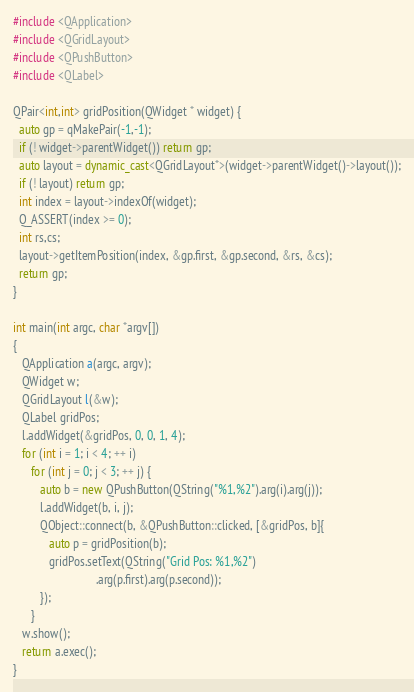Convert code to text. <code><loc_0><loc_0><loc_500><loc_500><_C++_>#include <QApplication>
#include <QGridLayout>
#include <QPushButton>
#include <QLabel>

QPair<int,int> gridPosition(QWidget * widget) {
  auto gp = qMakePair(-1,-1);
  if (! widget->parentWidget()) return gp;
  auto layout = dynamic_cast<QGridLayout*>(widget->parentWidget()->layout());
  if (! layout) return gp;
  int index = layout->indexOf(widget);
  Q_ASSERT(index >= 0);
  int rs,cs;
  layout->getItemPosition(index, &gp.first, &gp.second, &rs, &cs);
  return gp;
}

int main(int argc, char *argv[])
{
   QApplication a(argc, argv);
   QWidget w;
   QGridLayout l(&w);
   QLabel gridPos;
   l.addWidget(&gridPos, 0, 0, 1, 4);
   for (int i = 1; i < 4; ++ i)
      for (int j = 0; j < 3; ++ j) {
         auto b = new QPushButton(QString("%1,%2").arg(i).arg(j));
         l.addWidget(b, i, j);
         QObject::connect(b, &QPushButton::clicked, [&gridPos, b]{
            auto p = gridPosition(b);
            gridPos.setText(QString("Grid Pos: %1,%2")
                            .arg(p.first).arg(p.second));
         });
      }
   w.show();
   return a.exec();
}
</code> 